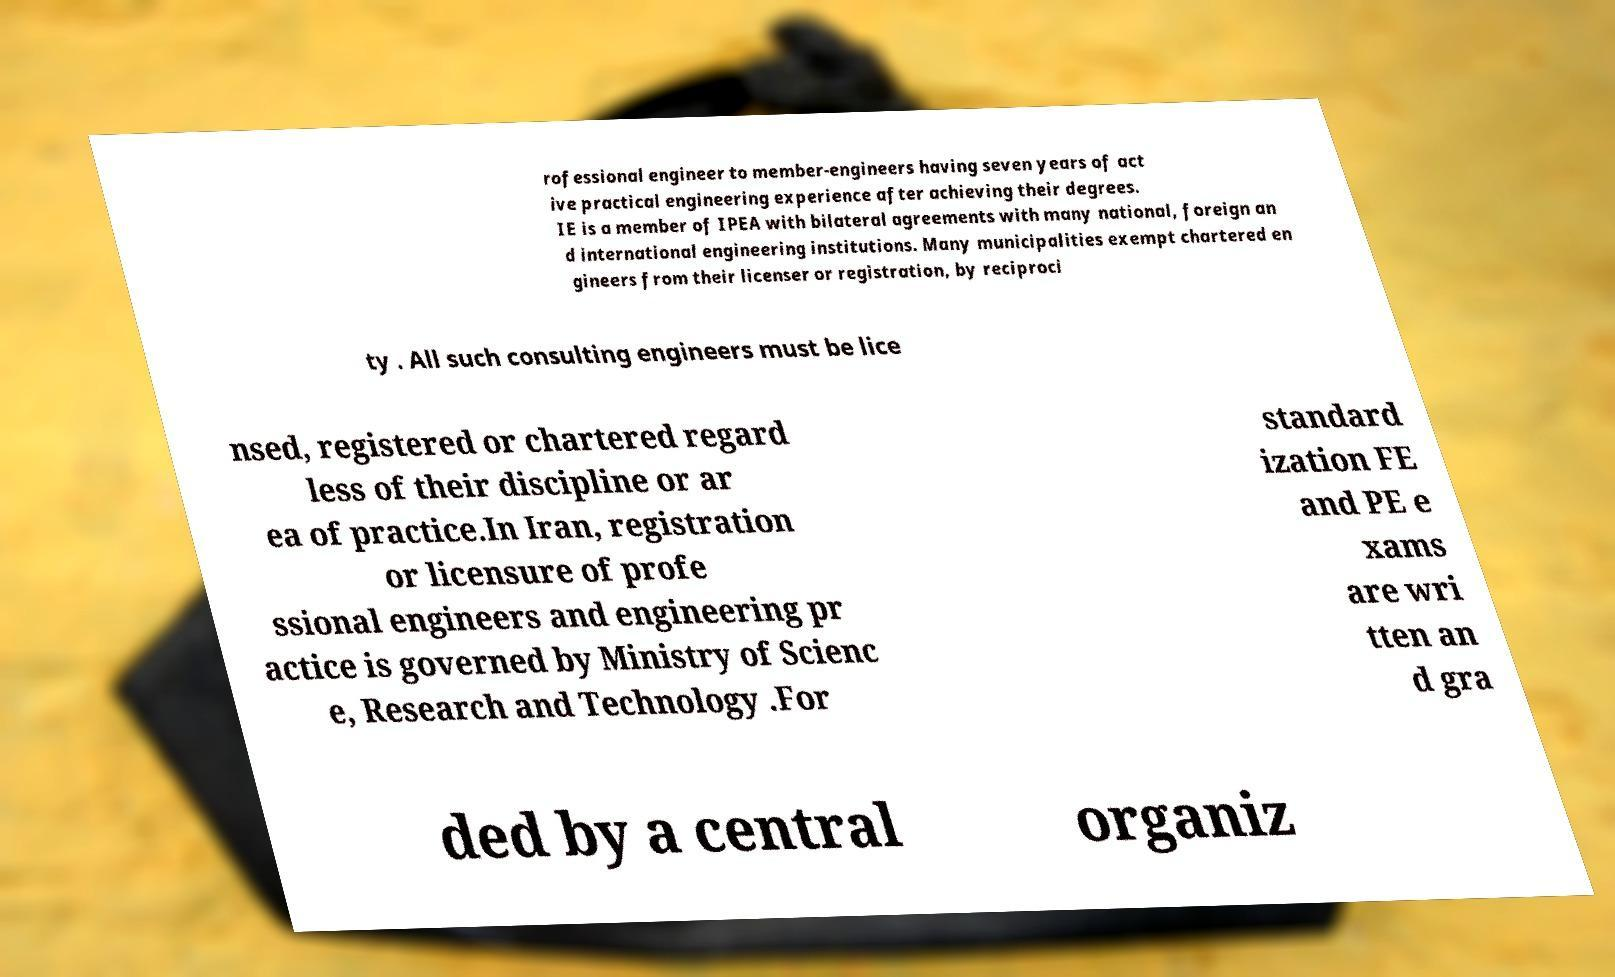Could you extract and type out the text from this image? rofessional engineer to member-engineers having seven years of act ive practical engineering experience after achieving their degrees. IE is a member of IPEA with bilateral agreements with many national, foreign an d international engineering institutions. Many municipalities exempt chartered en gineers from their licenser or registration, by reciproci ty . All such consulting engineers must be lice nsed, registered or chartered regard less of their discipline or ar ea of practice.In Iran, registration or licensure of profe ssional engineers and engineering pr actice is governed by Ministry of Scienc e, Research and Technology .For standard ization FE and PE e xams are wri tten an d gra ded by a central organiz 